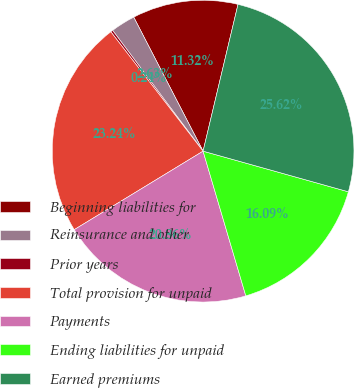<chart> <loc_0><loc_0><loc_500><loc_500><pie_chart><fcel>Beginning liabilities for<fcel>Reinsurance and other<fcel>Prior years<fcel>Total provision for unpaid<fcel>Payments<fcel>Ending liabilities for unpaid<fcel>Earned premiums<nl><fcel>11.32%<fcel>2.63%<fcel>0.24%<fcel>23.24%<fcel>20.86%<fcel>16.09%<fcel>25.62%<nl></chart> 